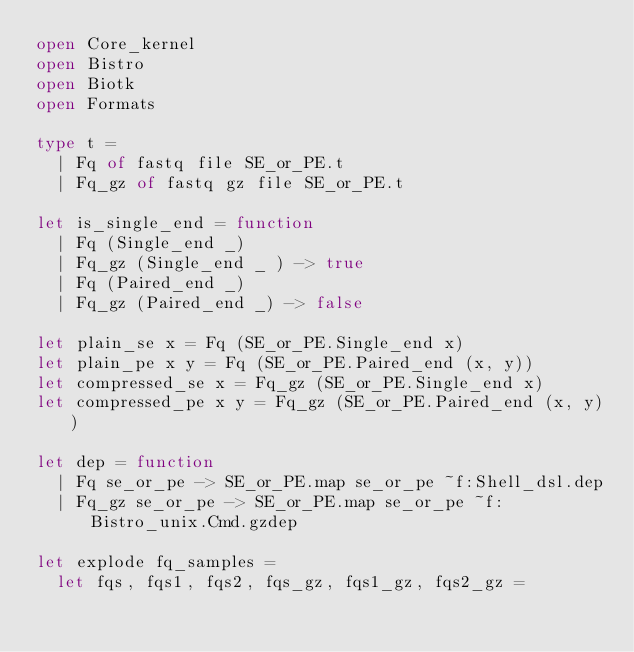Convert code to text. <code><loc_0><loc_0><loc_500><loc_500><_OCaml_>open Core_kernel
open Bistro
open Biotk
open Formats

type t =
  | Fq of fastq file SE_or_PE.t
  | Fq_gz of fastq gz file SE_or_PE.t

let is_single_end = function
  | Fq (Single_end _)
  | Fq_gz (Single_end _ ) -> true
  | Fq (Paired_end _)
  | Fq_gz (Paired_end _) -> false

let plain_se x = Fq (SE_or_PE.Single_end x)
let plain_pe x y = Fq (SE_or_PE.Paired_end (x, y))
let compressed_se x = Fq_gz (SE_or_PE.Single_end x)
let compressed_pe x y = Fq_gz (SE_or_PE.Paired_end (x, y))

let dep = function
  | Fq se_or_pe -> SE_or_PE.map se_or_pe ~f:Shell_dsl.dep
  | Fq_gz se_or_pe -> SE_or_PE.map se_or_pe ~f:Bistro_unix.Cmd.gzdep

let explode fq_samples =
  let fqs, fqs1, fqs2, fqs_gz, fqs1_gz, fqs2_gz =</code> 